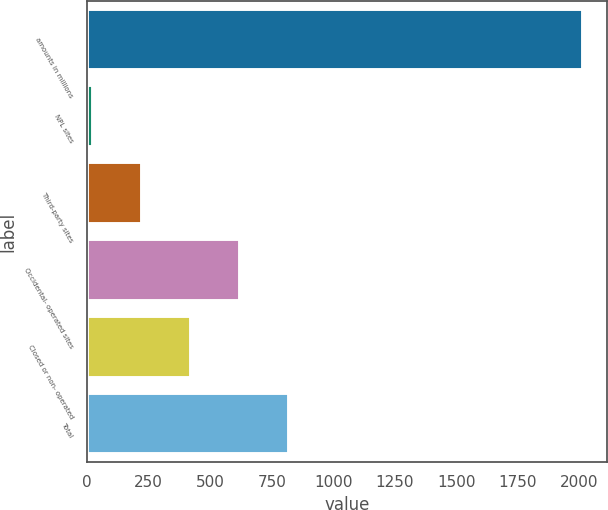<chart> <loc_0><loc_0><loc_500><loc_500><bar_chart><fcel>amounts in millions<fcel>NPL sites<fcel>Third-party sites<fcel>Occidental- operated sites<fcel>Closed or non- operated<fcel>Total<nl><fcel>2013<fcel>25<fcel>223.8<fcel>621.4<fcel>422.6<fcel>820.2<nl></chart> 